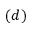Convert formula to latex. <formula><loc_0><loc_0><loc_500><loc_500>( d )</formula> 